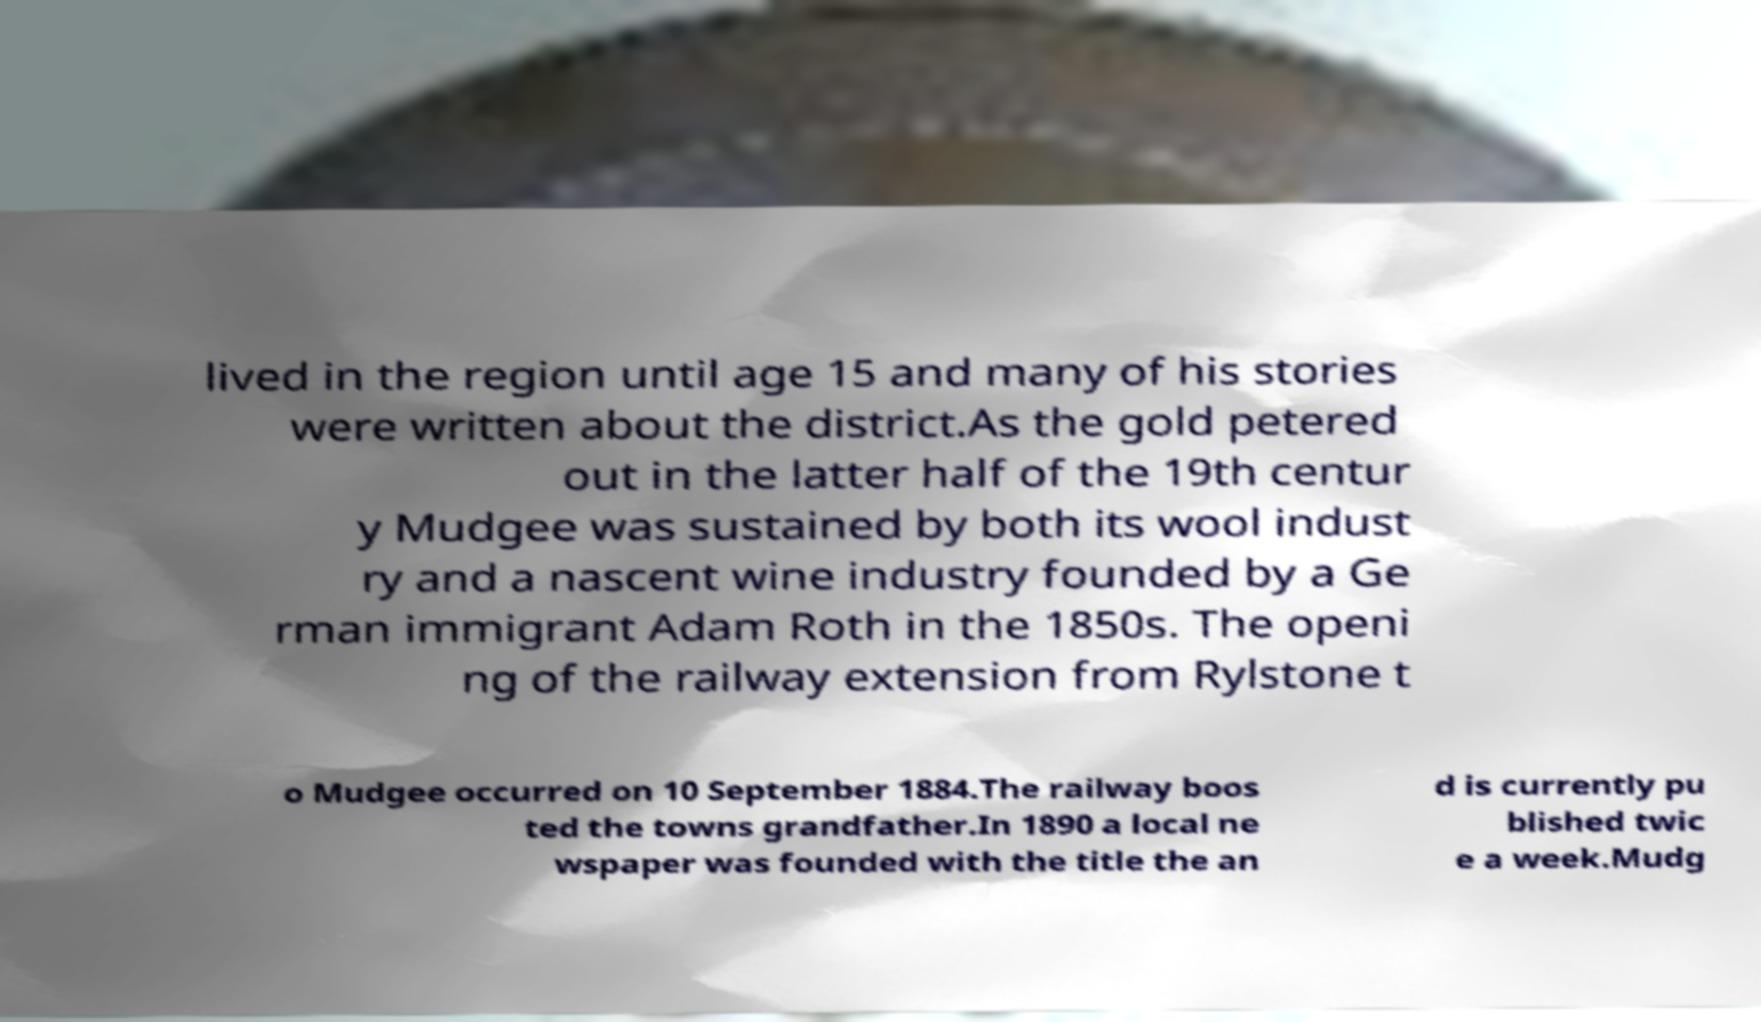What messages or text are displayed in this image? I need them in a readable, typed format. lived in the region until age 15 and many of his stories were written about the district.As the gold petered out in the latter half of the 19th centur y Mudgee was sustained by both its wool indust ry and a nascent wine industry founded by a Ge rman immigrant Adam Roth in the 1850s. The openi ng of the railway extension from Rylstone t o Mudgee occurred on 10 September 1884.The railway boos ted the towns grandfather.In 1890 a local ne wspaper was founded with the title the an d is currently pu blished twic e a week.Mudg 